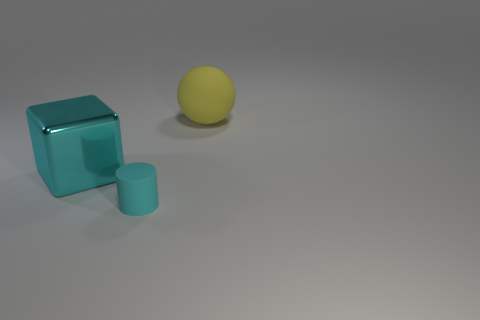What material is the big thing on the left side of the rubber thing right of the object that is in front of the big cyan cube?
Your answer should be compact. Metal. Are the big cyan block and the small cyan thing made of the same material?
Offer a terse response. No. What number of cylinders are small cyan objects or cyan metal objects?
Provide a short and direct response. 1. The matte object behind the small matte thing is what color?
Keep it short and to the point. Yellow. What number of metallic things are large gray objects or big spheres?
Ensure brevity in your answer.  0. There is a large thing that is to the left of the matte thing behind the cyan rubber cylinder; what is its material?
Your response must be concise. Metal. There is a small cylinder that is the same color as the shiny object; what is its material?
Provide a succinct answer. Rubber. What is the color of the tiny matte cylinder?
Give a very brief answer. Cyan. Are there any yellow things that are in front of the large thing behind the cube?
Provide a short and direct response. No. What is the large yellow thing made of?
Ensure brevity in your answer.  Rubber. 